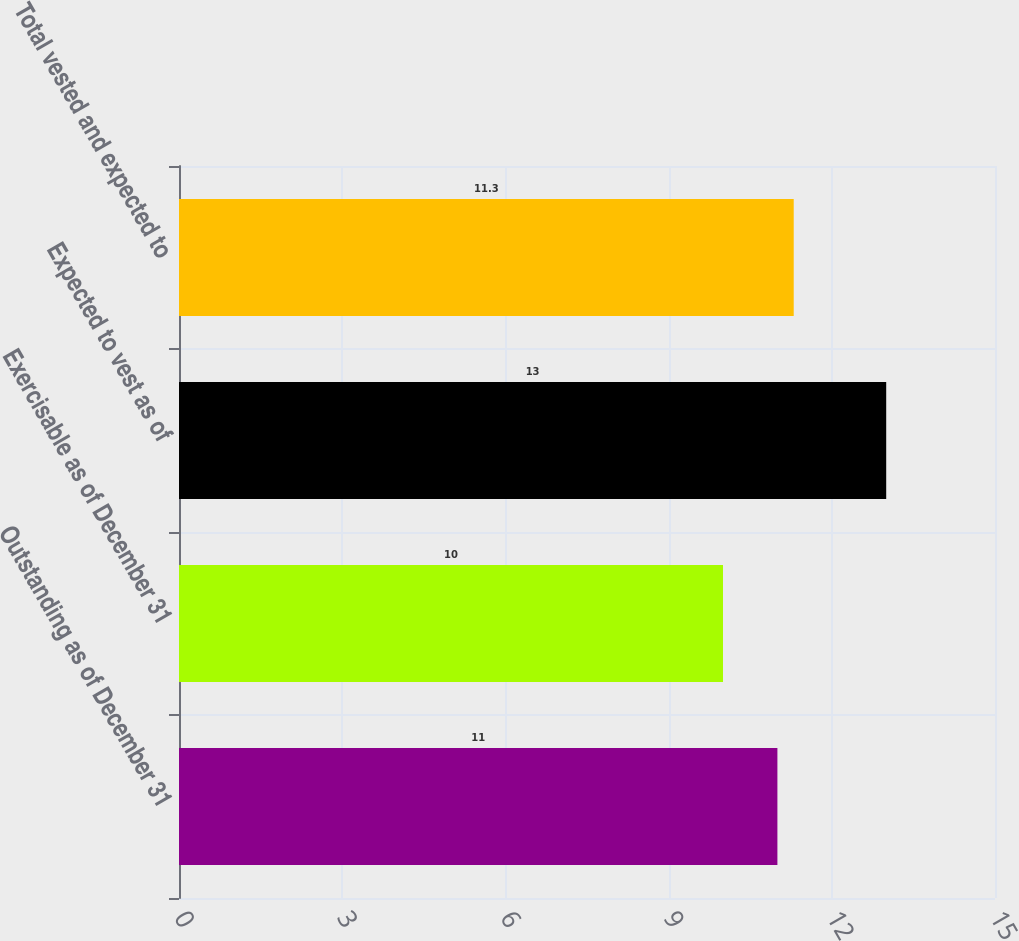<chart> <loc_0><loc_0><loc_500><loc_500><bar_chart><fcel>Outstanding as of December 31<fcel>Exercisable as of December 31<fcel>Expected to vest as of<fcel>Total vested and expected to<nl><fcel>11<fcel>10<fcel>13<fcel>11.3<nl></chart> 